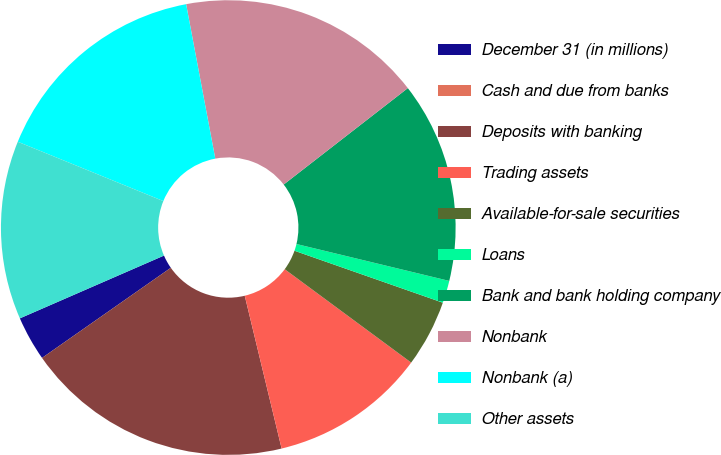Convert chart. <chart><loc_0><loc_0><loc_500><loc_500><pie_chart><fcel>December 31 (in millions)<fcel>Cash and due from banks<fcel>Deposits with banking<fcel>Trading assets<fcel>Available-for-sale securities<fcel>Loans<fcel>Bank and bank holding company<fcel>Nonbank<fcel>Nonbank (a)<fcel>Other assets<nl><fcel>3.18%<fcel>0.0%<fcel>19.05%<fcel>11.11%<fcel>4.76%<fcel>1.59%<fcel>14.28%<fcel>17.46%<fcel>15.87%<fcel>12.7%<nl></chart> 